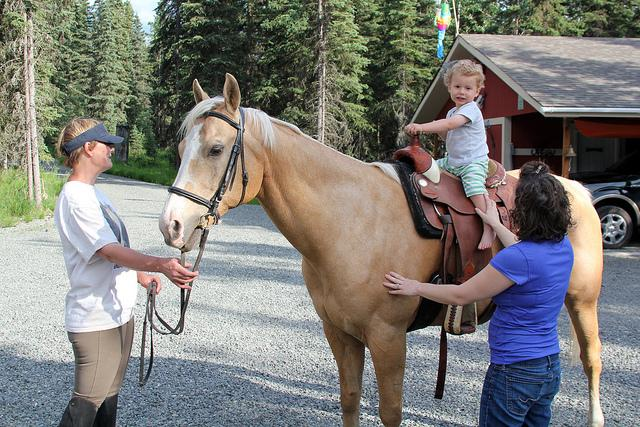Which one is probably the most proficient rider?

Choices:
A) striped pants
B) tan pants
C) none
D) blue pants tan pants 